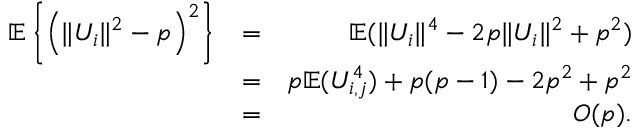<formula> <loc_0><loc_0><loc_500><loc_500>\begin{array} { r l r } { { \mathbb { E } } \left \{ \left ( \| U _ { i } \| ^ { 2 } - p \right ) ^ { 2 } \right \} } & { = } & { { \mathbb { E } } ( \| U _ { i } \| ^ { 4 } - 2 p \| U _ { i } \| ^ { 2 } + p ^ { 2 } ) } \\ & { = } & { p { \mathbb { E } } ( U _ { i , j } ^ { 4 } ) + p ( p - 1 ) - 2 p ^ { 2 } + p ^ { 2 } } \\ & { = } & { O ( p ) . } \end{array}</formula> 